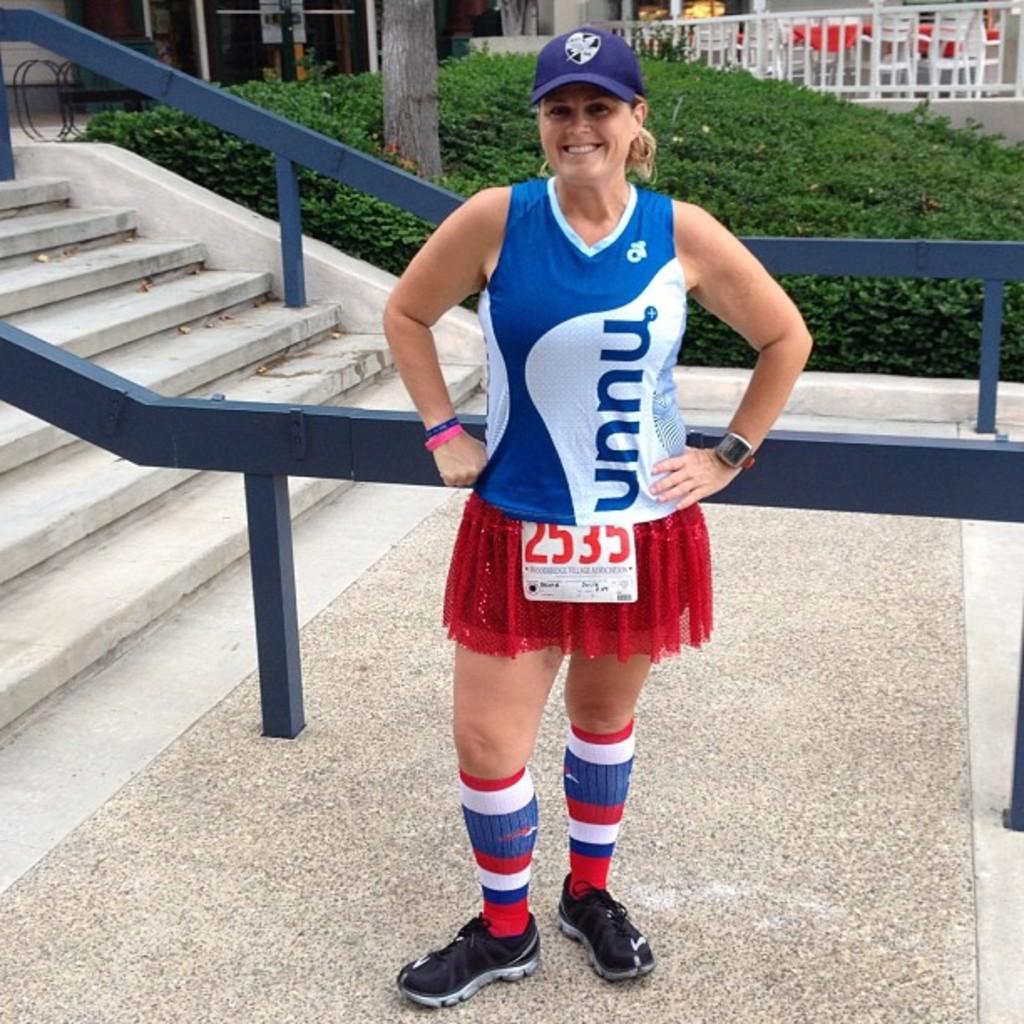<image>
Relay a brief, clear account of the picture shown. Runner number 2535 is wearing red, white and blue socks. 